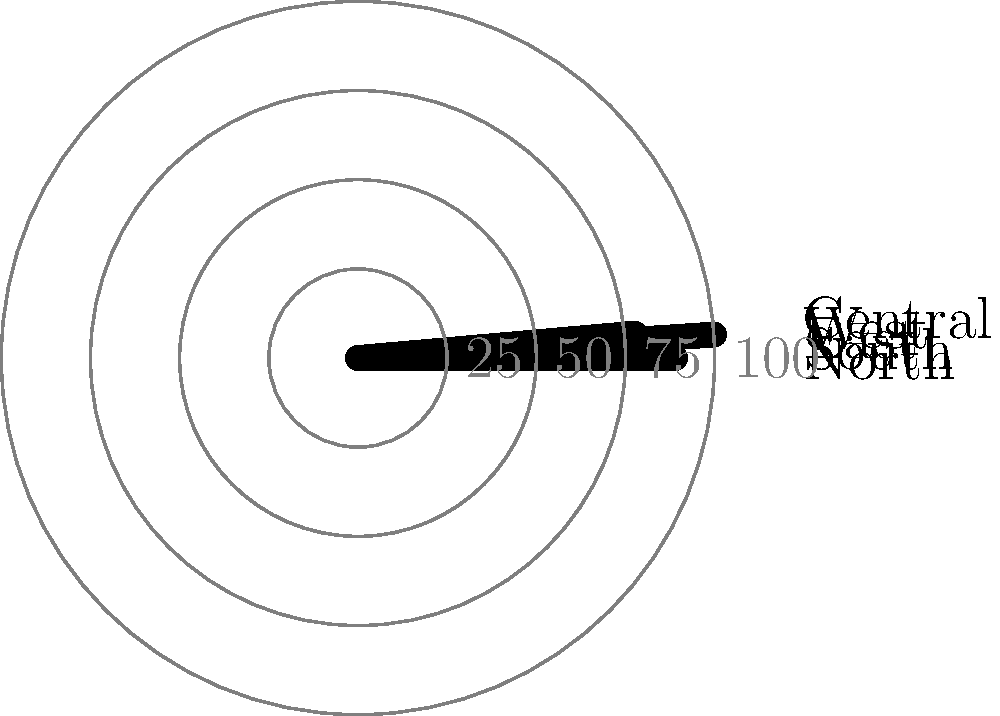Based on the polar bar chart showing HR key performance indicators across different regions, which region has the highest employee engagement score, and how much higher is it compared to the region with the lowest score? To answer this question, we need to follow these steps:

1. Identify the highest bar in the polar chart:
   The longest bar represents the highest score, which corresponds to the West region.

2. Identify the lowest bar in the polar chart:
   The shortest bar represents the lowest score, which corresponds to the South region.

3. Determine the values for these regions:
   West: 90 (the longest bar reaches the 90 mark)
   South: 65 (the shortest bar reaches the 65 mark)

4. Calculate the difference between the highest and lowest scores:
   $90 - 65 = 25$

Therefore, the West region has the highest employee engagement score, and it is 25 points higher than the South region, which has the lowest score.
Answer: West; 25 points higher 